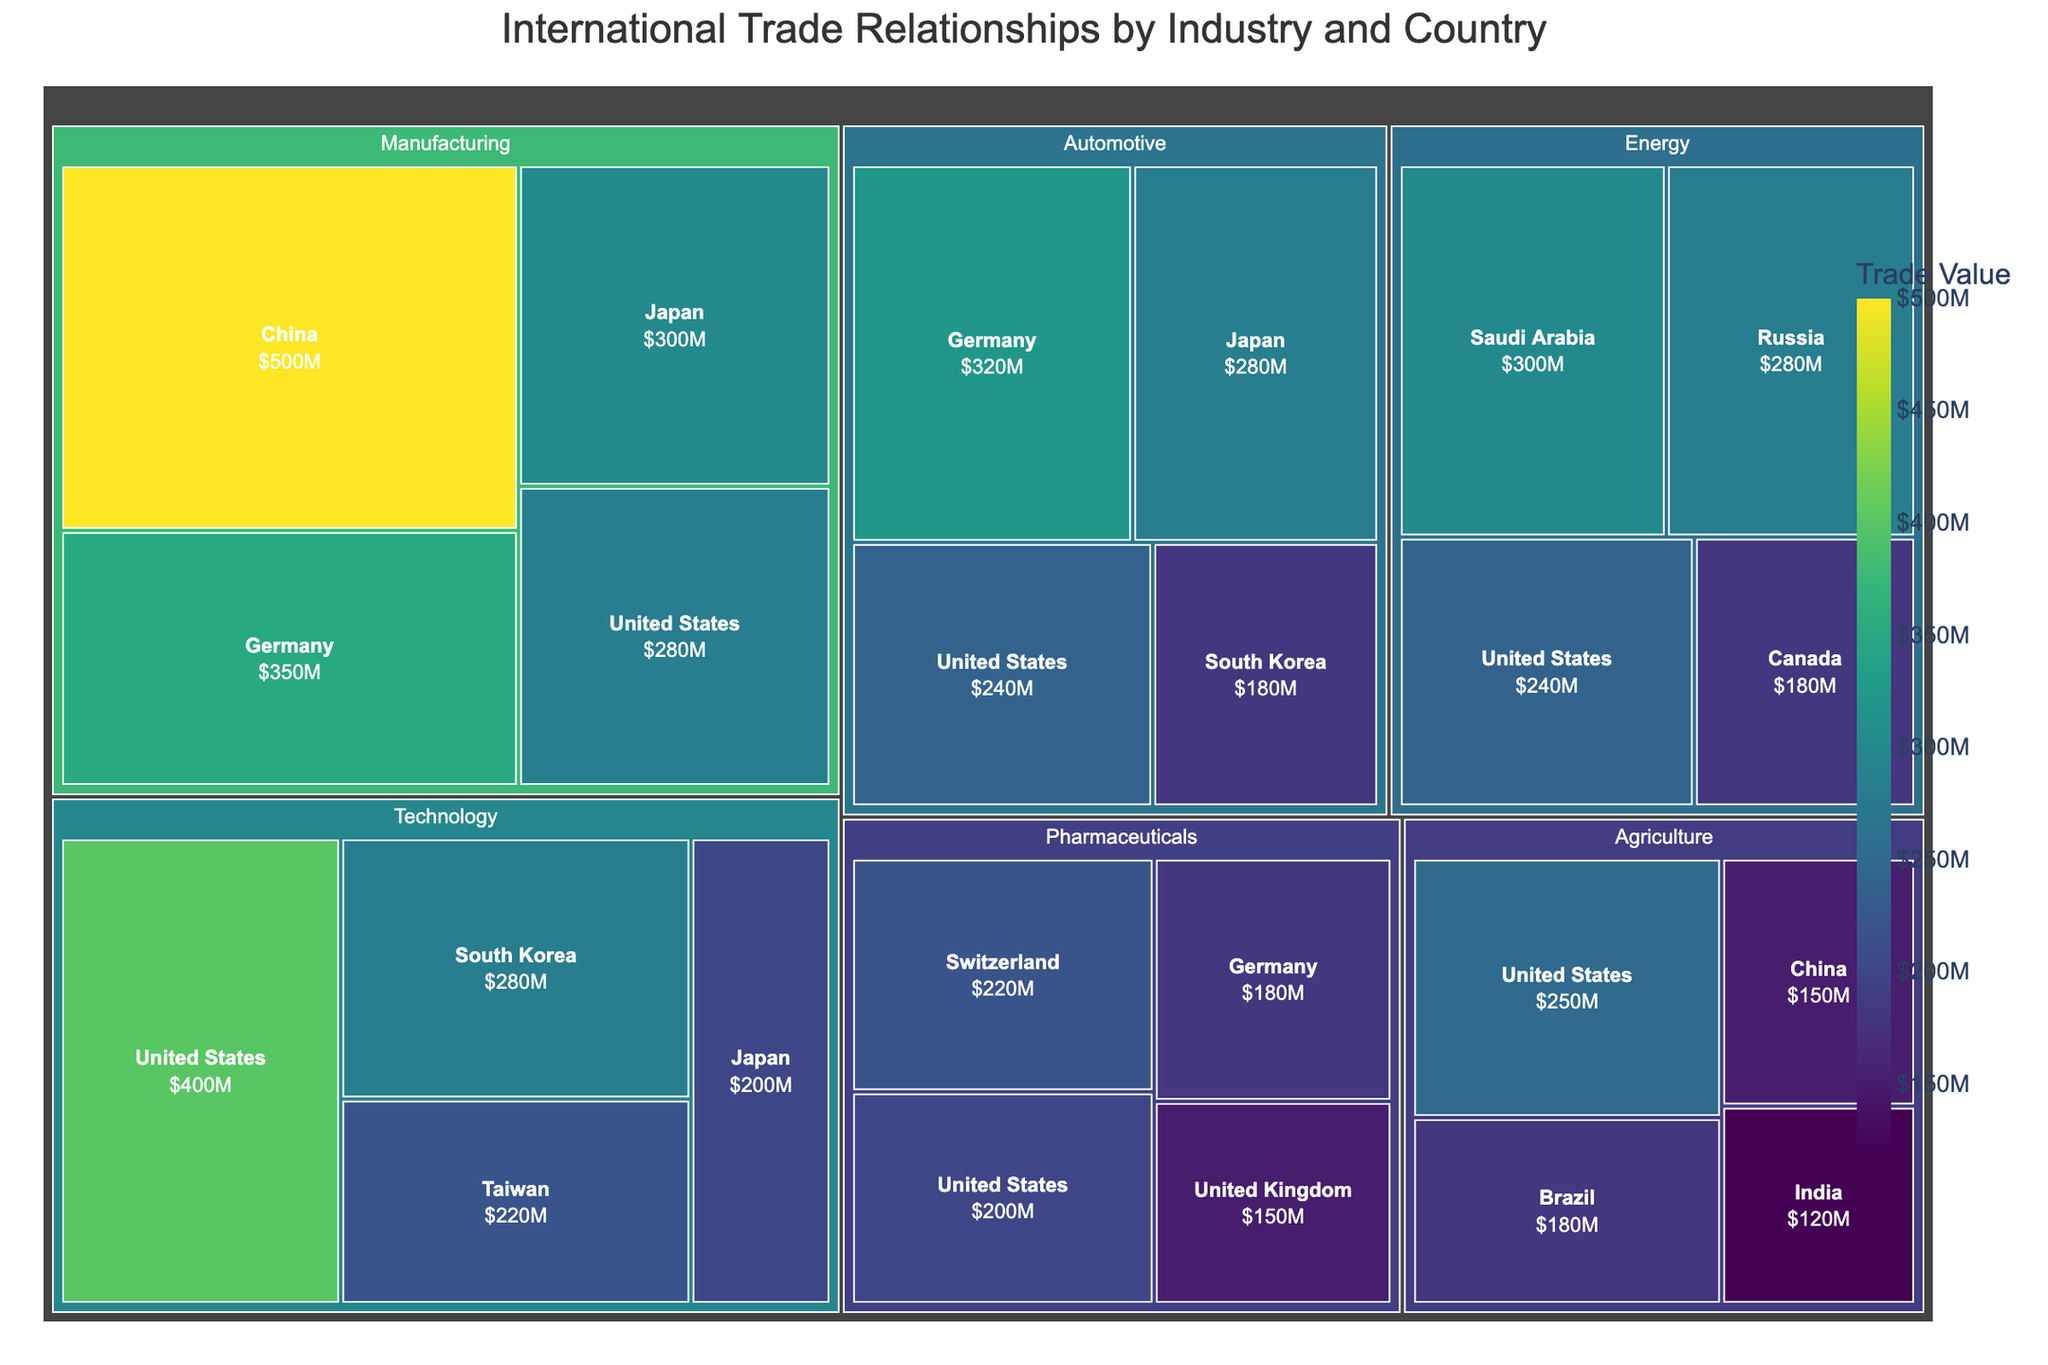What is the title of the Treemap? The title is displayed at the top center of the Treemap, giving us a brief description of the depicted data.
Answer: International Trade Relationships by Industry and Country Which country has the highest trade value in the Technology sector? Look for the Technology sector and check the trade values of the countries listed there. The United States has the highest value.
Answer: United States How does the trade value of Agriculture in China compare to Agriculture in India? Compare the areas representing China and India within the Agriculture sector. The trade value for China is $150M, whereas for India it is $120M.
Answer: China has a higher trade value than India What's the combined trade value of the Manufacturing sector from Germany and Japan? Add the trade values from Germany and Japan within the Manufacturing sector. The values are $350M and $300M respectively, leading to a combined trade value of $650M.
Answer: $650M Which industry has the highest trade value from Saudi Arabia? Identify the sector where Saudi Arabia is represented and note its trade value. The Energy sector has a trade value of $300M, which is the highest.
Answer: Energy What is the average trade value of the countries in the Automotive sector? Add trade values for all countries in the Automotive sector and divide by the number of countries (Germany: $320M, Japan: $280M, United States: $240M, South Korea: $180M). Total is $1020M; divided by 4 it gives us $255M.
Answer: $255M Which country appears in the most industry sectors? Count the number of different sectors in which each country appears. The United States appears in five sectors: Agriculture, Manufacturing, Technology, Energy, and Pharmaceuticals.
Answer: United States What is the smallest trade value in the Pharmaceuticals sector? Look at the Pharmaceuticals sector and identify the smallest value amongst the listed countries. It is for the United Kingdom at $150M.
Answer: $150M How does the trade value of Canada in the Energy sector compare to the trade value of South Korea in the Automotive sector? Compare the values of Canada in Energy ($180M) and South Korea in Automotive ($180M). Both have the same trade value.
Answer: Equal 